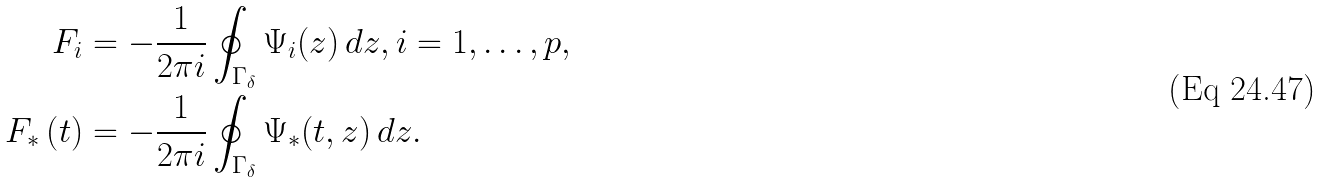Convert formula to latex. <formula><loc_0><loc_0><loc_500><loc_500>{ F } _ { i } & = - \frac { 1 } { 2 \pi i } \oint _ { \Gamma _ { \delta } } \Psi _ { i } ( z ) \, d z , i = 1 , \dots , p , \\ { F } _ { * } \left ( t \right ) & = - \frac { 1 } { 2 \pi i } \oint _ { \Gamma _ { \delta } } \Psi _ { * } ( t , z ) \, d z .</formula> 